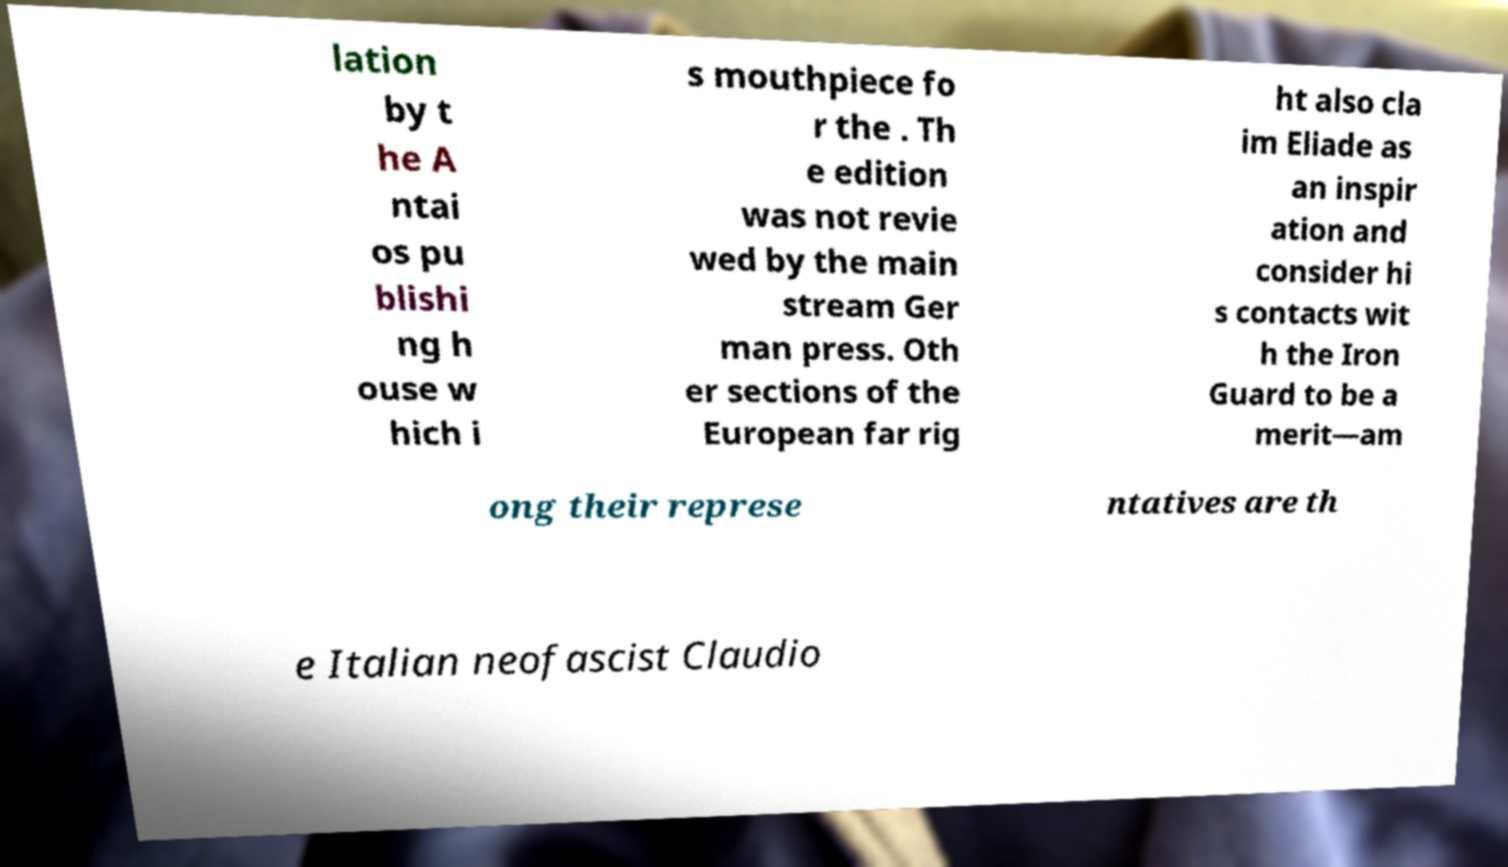There's text embedded in this image that I need extracted. Can you transcribe it verbatim? lation by t he A ntai os pu blishi ng h ouse w hich i s mouthpiece fo r the . Th e edition was not revie wed by the main stream Ger man press. Oth er sections of the European far rig ht also cla im Eliade as an inspir ation and consider hi s contacts wit h the Iron Guard to be a merit—am ong their represe ntatives are th e Italian neofascist Claudio 